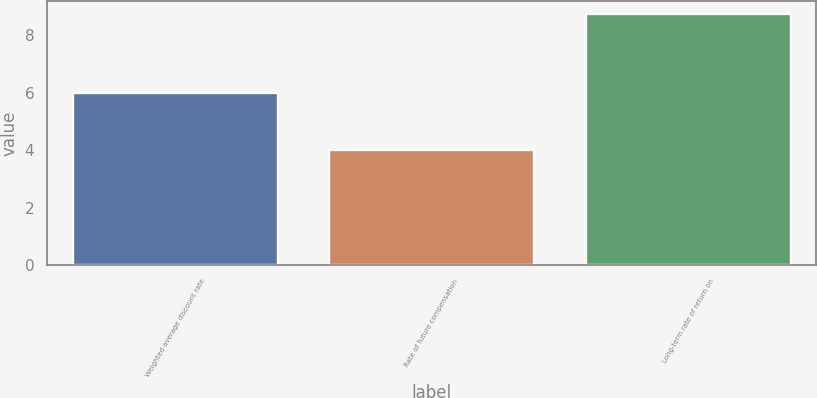Convert chart. <chart><loc_0><loc_0><loc_500><loc_500><bar_chart><fcel>Weighted average discount rate<fcel>Rate of future compensation<fcel>Long-term rate of return on<nl><fcel>6<fcel>4<fcel>8.75<nl></chart> 